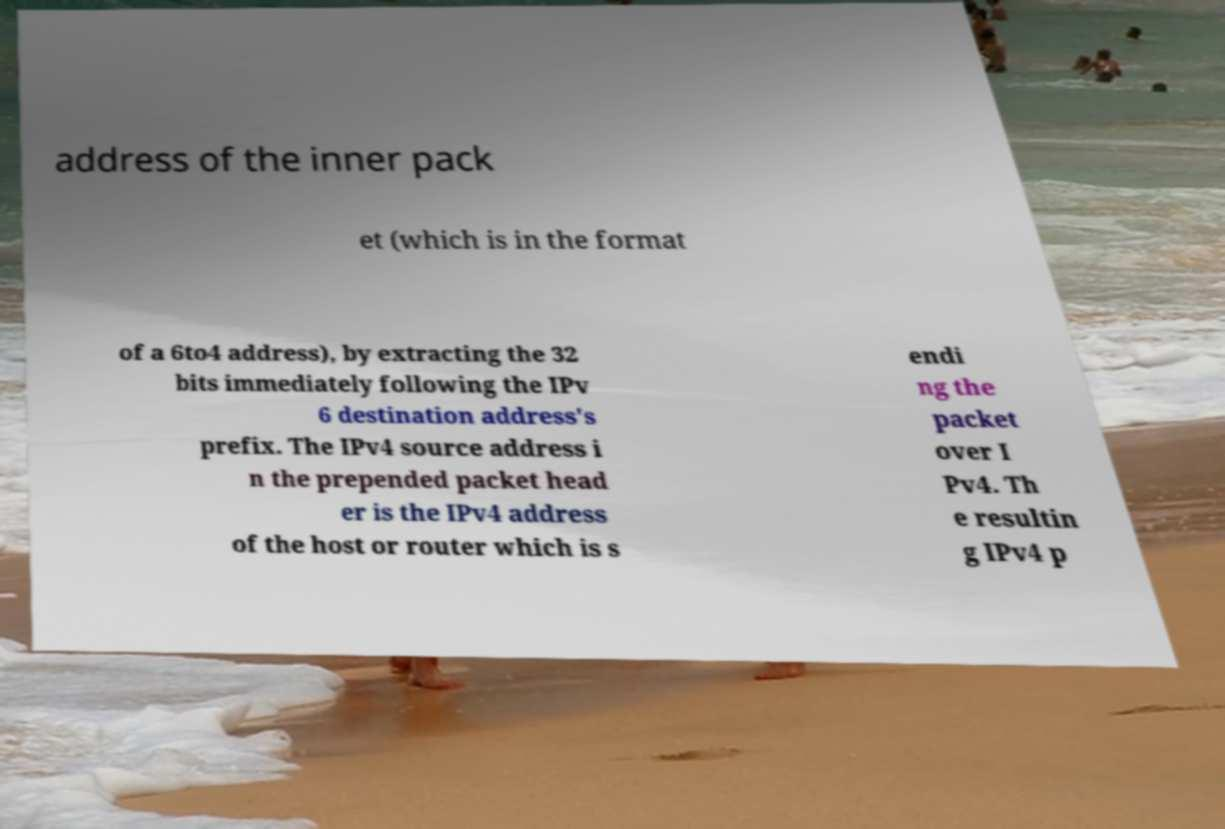Could you extract and type out the text from this image? address of the inner pack et (which is in the format of a 6to4 address), by extracting the 32 bits immediately following the IPv 6 destination address's prefix. The IPv4 source address i n the prepended packet head er is the IPv4 address of the host or router which is s endi ng the packet over I Pv4. Th e resultin g IPv4 p 